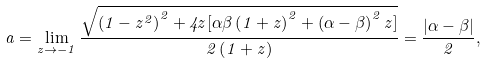Convert formula to latex. <formula><loc_0><loc_0><loc_500><loc_500>a = \lim _ { z \rightarrow - 1 } \frac { \sqrt { \left ( 1 - z ^ { 2 } \right ) ^ { 2 } + 4 z [ \alpha \beta \left ( 1 + z \right ) ^ { 2 } + \left ( \alpha - \beta \right ) ^ { 2 } z ] } } { 2 \left ( 1 + z \right ) } = \frac { | \alpha - \beta | } { 2 } ,</formula> 